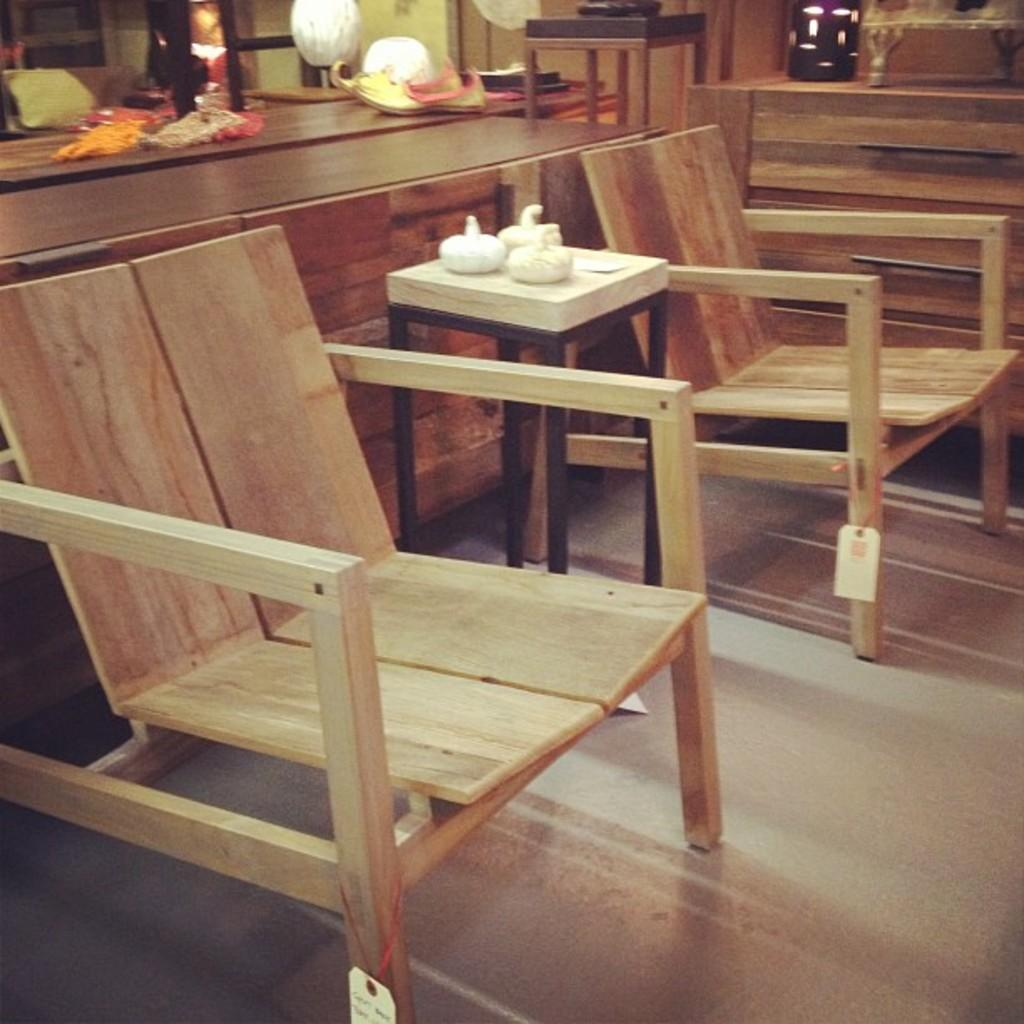What type of furniture is present in the image? There are wooden chairs in the image. Can you describe the arrangement of the furniture? There is a stool between the wooden chairs. What is located behind the chairs? There is a desk behind the chairs. What can be seen on the desk? There are items placed on the desk. How many brothers are sitting on the wooden chairs in the image? There is no information about brothers or people sitting on the chairs in the image. 